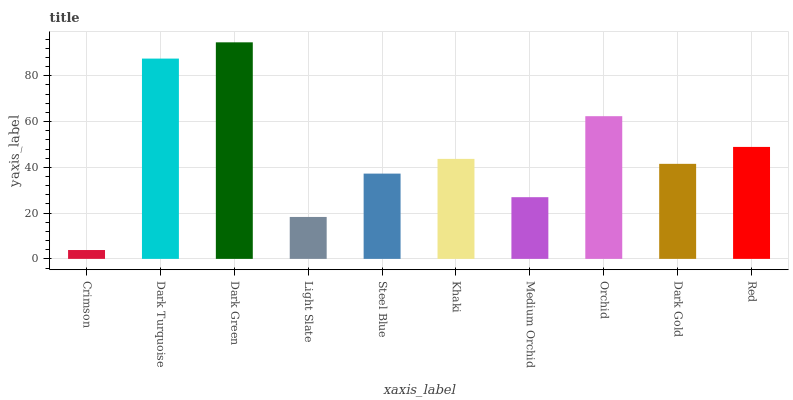Is Crimson the minimum?
Answer yes or no. Yes. Is Dark Green the maximum?
Answer yes or no. Yes. Is Dark Turquoise the minimum?
Answer yes or no. No. Is Dark Turquoise the maximum?
Answer yes or no. No. Is Dark Turquoise greater than Crimson?
Answer yes or no. Yes. Is Crimson less than Dark Turquoise?
Answer yes or no. Yes. Is Crimson greater than Dark Turquoise?
Answer yes or no. No. Is Dark Turquoise less than Crimson?
Answer yes or no. No. Is Khaki the high median?
Answer yes or no. Yes. Is Dark Gold the low median?
Answer yes or no. Yes. Is Dark Green the high median?
Answer yes or no. No. Is Orchid the low median?
Answer yes or no. No. 